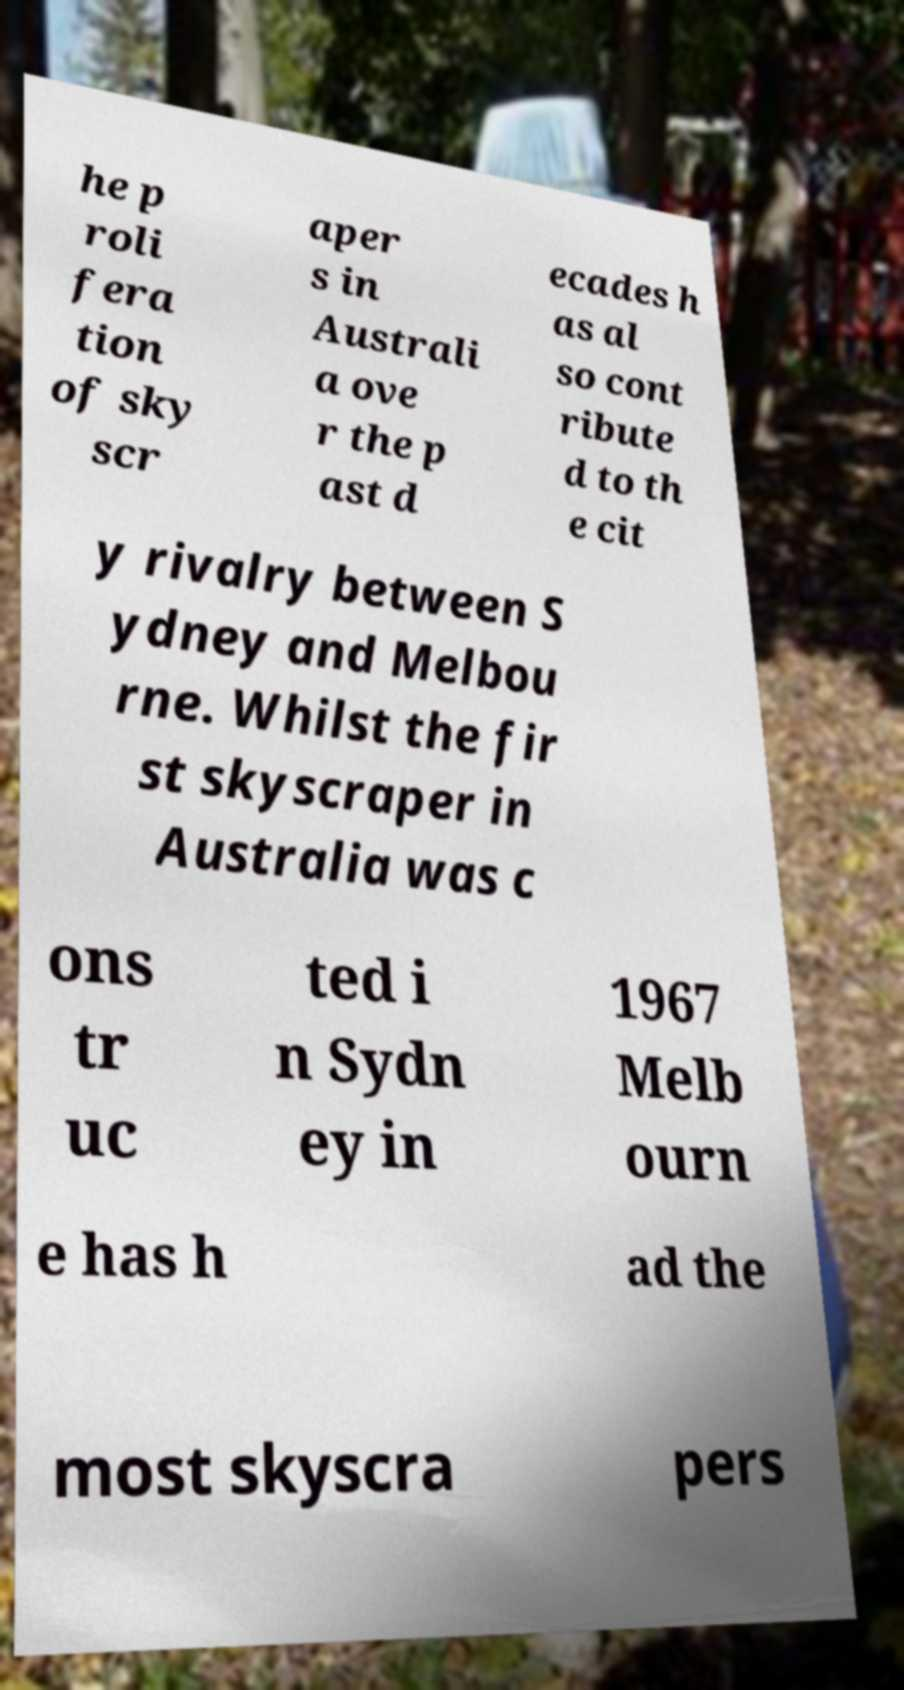Please read and relay the text visible in this image. What does it say? he p roli fera tion of sky scr aper s in Australi a ove r the p ast d ecades h as al so cont ribute d to th e cit y rivalry between S ydney and Melbou rne. Whilst the fir st skyscraper in Australia was c ons tr uc ted i n Sydn ey in 1967 Melb ourn e has h ad the most skyscra pers 